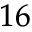<formula> <loc_0><loc_0><loc_500><loc_500>_ { 1 6 }</formula> 